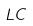<formula> <loc_0><loc_0><loc_500><loc_500>L C</formula> 